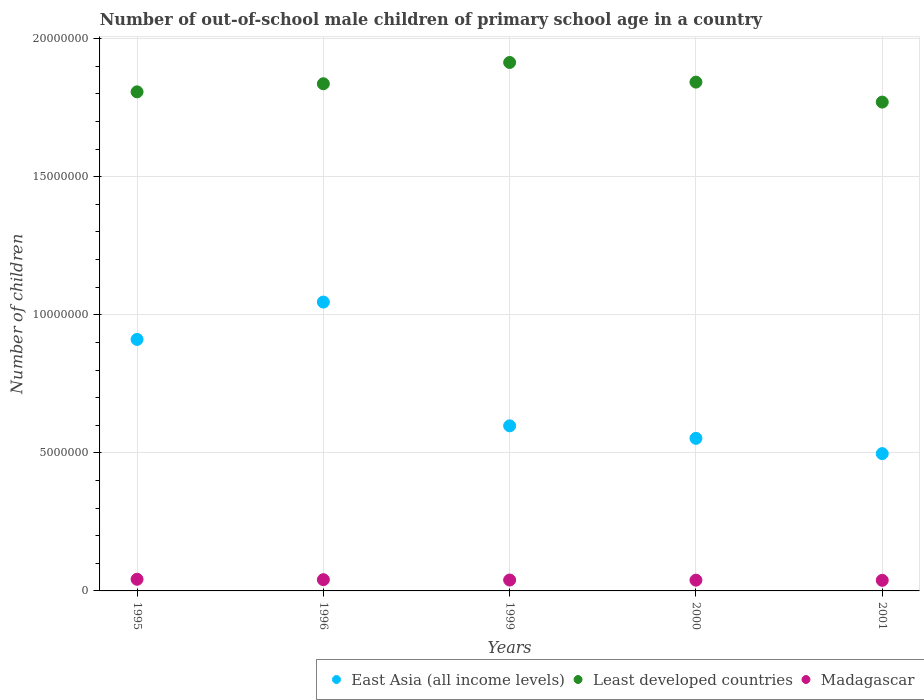Is the number of dotlines equal to the number of legend labels?
Offer a very short reply. Yes. What is the number of out-of-school male children in Madagascar in 1999?
Offer a terse response. 3.95e+05. Across all years, what is the maximum number of out-of-school male children in Madagascar?
Your answer should be very brief. 4.22e+05. Across all years, what is the minimum number of out-of-school male children in Least developed countries?
Offer a very short reply. 1.77e+07. In which year was the number of out-of-school male children in Least developed countries minimum?
Ensure brevity in your answer.  2001. What is the total number of out-of-school male children in Least developed countries in the graph?
Provide a succinct answer. 9.17e+07. What is the difference between the number of out-of-school male children in Least developed countries in 1996 and that in 2000?
Your response must be concise. -6.03e+04. What is the difference between the number of out-of-school male children in Least developed countries in 2001 and the number of out-of-school male children in East Asia (all income levels) in 2000?
Your response must be concise. 1.22e+07. What is the average number of out-of-school male children in Least developed countries per year?
Offer a very short reply. 1.83e+07. In the year 1995, what is the difference between the number of out-of-school male children in East Asia (all income levels) and number of out-of-school male children in Madagascar?
Ensure brevity in your answer.  8.69e+06. In how many years, is the number of out-of-school male children in East Asia (all income levels) greater than 6000000?
Give a very brief answer. 2. What is the ratio of the number of out-of-school male children in Least developed countries in 1995 to that in 2001?
Provide a short and direct response. 1.02. What is the difference between the highest and the second highest number of out-of-school male children in Madagascar?
Provide a short and direct response. 1.47e+04. What is the difference between the highest and the lowest number of out-of-school male children in East Asia (all income levels)?
Give a very brief answer. 5.49e+06. In how many years, is the number of out-of-school male children in Madagascar greater than the average number of out-of-school male children in Madagascar taken over all years?
Provide a succinct answer. 2. Is it the case that in every year, the sum of the number of out-of-school male children in East Asia (all income levels) and number of out-of-school male children in Madagascar  is greater than the number of out-of-school male children in Least developed countries?
Your answer should be very brief. No. Does the number of out-of-school male children in East Asia (all income levels) monotonically increase over the years?
Offer a terse response. No. Is the number of out-of-school male children in Least developed countries strictly less than the number of out-of-school male children in Madagascar over the years?
Offer a very short reply. No. Are the values on the major ticks of Y-axis written in scientific E-notation?
Ensure brevity in your answer.  No. Does the graph contain grids?
Offer a terse response. Yes. How many legend labels are there?
Provide a short and direct response. 3. What is the title of the graph?
Make the answer very short. Number of out-of-school male children of primary school age in a country. Does "Australia" appear as one of the legend labels in the graph?
Ensure brevity in your answer.  No. What is the label or title of the X-axis?
Keep it short and to the point. Years. What is the label or title of the Y-axis?
Ensure brevity in your answer.  Number of children. What is the Number of children of East Asia (all income levels) in 1995?
Your response must be concise. 9.11e+06. What is the Number of children in Least developed countries in 1995?
Your answer should be very brief. 1.81e+07. What is the Number of children in Madagascar in 1995?
Offer a terse response. 4.22e+05. What is the Number of children of East Asia (all income levels) in 1996?
Your answer should be very brief. 1.05e+07. What is the Number of children in Least developed countries in 1996?
Your answer should be very brief. 1.84e+07. What is the Number of children of Madagascar in 1996?
Your response must be concise. 4.07e+05. What is the Number of children in East Asia (all income levels) in 1999?
Make the answer very short. 5.98e+06. What is the Number of children in Least developed countries in 1999?
Give a very brief answer. 1.91e+07. What is the Number of children of Madagascar in 1999?
Your answer should be very brief. 3.95e+05. What is the Number of children in East Asia (all income levels) in 2000?
Offer a very short reply. 5.53e+06. What is the Number of children of Least developed countries in 2000?
Your answer should be compact. 1.84e+07. What is the Number of children of Madagascar in 2000?
Your answer should be compact. 3.90e+05. What is the Number of children of East Asia (all income levels) in 2001?
Offer a terse response. 4.97e+06. What is the Number of children in Least developed countries in 2001?
Keep it short and to the point. 1.77e+07. What is the Number of children in Madagascar in 2001?
Offer a terse response. 3.83e+05. Across all years, what is the maximum Number of children in East Asia (all income levels)?
Give a very brief answer. 1.05e+07. Across all years, what is the maximum Number of children in Least developed countries?
Offer a terse response. 1.91e+07. Across all years, what is the maximum Number of children in Madagascar?
Give a very brief answer. 4.22e+05. Across all years, what is the minimum Number of children of East Asia (all income levels)?
Your answer should be compact. 4.97e+06. Across all years, what is the minimum Number of children in Least developed countries?
Give a very brief answer. 1.77e+07. Across all years, what is the minimum Number of children of Madagascar?
Provide a succinct answer. 3.83e+05. What is the total Number of children in East Asia (all income levels) in the graph?
Your response must be concise. 3.60e+07. What is the total Number of children in Least developed countries in the graph?
Your response must be concise. 9.17e+07. What is the total Number of children of Madagascar in the graph?
Keep it short and to the point. 2.00e+06. What is the difference between the Number of children in East Asia (all income levels) in 1995 and that in 1996?
Give a very brief answer. -1.35e+06. What is the difference between the Number of children of Least developed countries in 1995 and that in 1996?
Provide a succinct answer. -2.93e+05. What is the difference between the Number of children in Madagascar in 1995 and that in 1996?
Provide a short and direct response. 1.47e+04. What is the difference between the Number of children in East Asia (all income levels) in 1995 and that in 1999?
Offer a very short reply. 3.13e+06. What is the difference between the Number of children of Least developed countries in 1995 and that in 1999?
Give a very brief answer. -1.06e+06. What is the difference between the Number of children in Madagascar in 1995 and that in 1999?
Your response must be concise. 2.75e+04. What is the difference between the Number of children of East Asia (all income levels) in 1995 and that in 2000?
Ensure brevity in your answer.  3.58e+06. What is the difference between the Number of children of Least developed countries in 1995 and that in 2000?
Make the answer very short. -3.53e+05. What is the difference between the Number of children of Madagascar in 1995 and that in 2000?
Keep it short and to the point. 3.25e+04. What is the difference between the Number of children of East Asia (all income levels) in 1995 and that in 2001?
Offer a very short reply. 4.14e+06. What is the difference between the Number of children of Least developed countries in 1995 and that in 2001?
Your response must be concise. 3.71e+05. What is the difference between the Number of children of Madagascar in 1995 and that in 2001?
Provide a short and direct response. 3.88e+04. What is the difference between the Number of children of East Asia (all income levels) in 1996 and that in 1999?
Your response must be concise. 4.48e+06. What is the difference between the Number of children of Least developed countries in 1996 and that in 1999?
Keep it short and to the point. -7.71e+05. What is the difference between the Number of children in Madagascar in 1996 and that in 1999?
Your answer should be compact. 1.28e+04. What is the difference between the Number of children of East Asia (all income levels) in 1996 and that in 2000?
Offer a terse response. 4.94e+06. What is the difference between the Number of children of Least developed countries in 1996 and that in 2000?
Provide a short and direct response. -6.03e+04. What is the difference between the Number of children in Madagascar in 1996 and that in 2000?
Ensure brevity in your answer.  1.79e+04. What is the difference between the Number of children in East Asia (all income levels) in 1996 and that in 2001?
Make the answer very short. 5.49e+06. What is the difference between the Number of children of Least developed countries in 1996 and that in 2001?
Offer a very short reply. 6.64e+05. What is the difference between the Number of children in Madagascar in 1996 and that in 2001?
Provide a succinct answer. 2.41e+04. What is the difference between the Number of children in East Asia (all income levels) in 1999 and that in 2000?
Ensure brevity in your answer.  4.53e+05. What is the difference between the Number of children in Least developed countries in 1999 and that in 2000?
Your response must be concise. 7.11e+05. What is the difference between the Number of children in Madagascar in 1999 and that in 2000?
Offer a terse response. 5055. What is the difference between the Number of children in East Asia (all income levels) in 1999 and that in 2001?
Ensure brevity in your answer.  1.01e+06. What is the difference between the Number of children of Least developed countries in 1999 and that in 2001?
Provide a short and direct response. 1.44e+06. What is the difference between the Number of children in Madagascar in 1999 and that in 2001?
Make the answer very short. 1.13e+04. What is the difference between the Number of children in East Asia (all income levels) in 2000 and that in 2001?
Make the answer very short. 5.53e+05. What is the difference between the Number of children of Least developed countries in 2000 and that in 2001?
Offer a terse response. 7.24e+05. What is the difference between the Number of children in Madagascar in 2000 and that in 2001?
Provide a succinct answer. 6256. What is the difference between the Number of children in East Asia (all income levels) in 1995 and the Number of children in Least developed countries in 1996?
Offer a terse response. -9.26e+06. What is the difference between the Number of children of East Asia (all income levels) in 1995 and the Number of children of Madagascar in 1996?
Make the answer very short. 8.70e+06. What is the difference between the Number of children of Least developed countries in 1995 and the Number of children of Madagascar in 1996?
Ensure brevity in your answer.  1.77e+07. What is the difference between the Number of children in East Asia (all income levels) in 1995 and the Number of children in Least developed countries in 1999?
Provide a succinct answer. -1.00e+07. What is the difference between the Number of children of East Asia (all income levels) in 1995 and the Number of children of Madagascar in 1999?
Make the answer very short. 8.71e+06. What is the difference between the Number of children of Least developed countries in 1995 and the Number of children of Madagascar in 1999?
Provide a short and direct response. 1.77e+07. What is the difference between the Number of children in East Asia (all income levels) in 1995 and the Number of children in Least developed countries in 2000?
Make the answer very short. -9.32e+06. What is the difference between the Number of children of East Asia (all income levels) in 1995 and the Number of children of Madagascar in 2000?
Provide a succinct answer. 8.72e+06. What is the difference between the Number of children of Least developed countries in 1995 and the Number of children of Madagascar in 2000?
Your response must be concise. 1.77e+07. What is the difference between the Number of children of East Asia (all income levels) in 1995 and the Number of children of Least developed countries in 2001?
Make the answer very short. -8.59e+06. What is the difference between the Number of children in East Asia (all income levels) in 1995 and the Number of children in Madagascar in 2001?
Offer a very short reply. 8.72e+06. What is the difference between the Number of children of Least developed countries in 1995 and the Number of children of Madagascar in 2001?
Offer a very short reply. 1.77e+07. What is the difference between the Number of children of East Asia (all income levels) in 1996 and the Number of children of Least developed countries in 1999?
Give a very brief answer. -8.68e+06. What is the difference between the Number of children of East Asia (all income levels) in 1996 and the Number of children of Madagascar in 1999?
Provide a short and direct response. 1.01e+07. What is the difference between the Number of children in Least developed countries in 1996 and the Number of children in Madagascar in 1999?
Keep it short and to the point. 1.80e+07. What is the difference between the Number of children of East Asia (all income levels) in 1996 and the Number of children of Least developed countries in 2000?
Your answer should be very brief. -7.97e+06. What is the difference between the Number of children of East Asia (all income levels) in 1996 and the Number of children of Madagascar in 2000?
Your response must be concise. 1.01e+07. What is the difference between the Number of children of Least developed countries in 1996 and the Number of children of Madagascar in 2000?
Your answer should be very brief. 1.80e+07. What is the difference between the Number of children in East Asia (all income levels) in 1996 and the Number of children in Least developed countries in 2001?
Keep it short and to the point. -7.24e+06. What is the difference between the Number of children in East Asia (all income levels) in 1996 and the Number of children in Madagascar in 2001?
Give a very brief answer. 1.01e+07. What is the difference between the Number of children of Least developed countries in 1996 and the Number of children of Madagascar in 2001?
Make the answer very short. 1.80e+07. What is the difference between the Number of children in East Asia (all income levels) in 1999 and the Number of children in Least developed countries in 2000?
Provide a short and direct response. -1.24e+07. What is the difference between the Number of children in East Asia (all income levels) in 1999 and the Number of children in Madagascar in 2000?
Make the answer very short. 5.59e+06. What is the difference between the Number of children in Least developed countries in 1999 and the Number of children in Madagascar in 2000?
Keep it short and to the point. 1.87e+07. What is the difference between the Number of children of East Asia (all income levels) in 1999 and the Number of children of Least developed countries in 2001?
Keep it short and to the point. -1.17e+07. What is the difference between the Number of children in East Asia (all income levels) in 1999 and the Number of children in Madagascar in 2001?
Your answer should be compact. 5.60e+06. What is the difference between the Number of children of Least developed countries in 1999 and the Number of children of Madagascar in 2001?
Ensure brevity in your answer.  1.88e+07. What is the difference between the Number of children in East Asia (all income levels) in 2000 and the Number of children in Least developed countries in 2001?
Ensure brevity in your answer.  -1.22e+07. What is the difference between the Number of children of East Asia (all income levels) in 2000 and the Number of children of Madagascar in 2001?
Offer a very short reply. 5.14e+06. What is the difference between the Number of children of Least developed countries in 2000 and the Number of children of Madagascar in 2001?
Your answer should be very brief. 1.80e+07. What is the average Number of children in East Asia (all income levels) per year?
Give a very brief answer. 7.21e+06. What is the average Number of children in Least developed countries per year?
Offer a very short reply. 1.83e+07. What is the average Number of children of Madagascar per year?
Make the answer very short. 3.99e+05. In the year 1995, what is the difference between the Number of children of East Asia (all income levels) and Number of children of Least developed countries?
Provide a short and direct response. -8.97e+06. In the year 1995, what is the difference between the Number of children of East Asia (all income levels) and Number of children of Madagascar?
Ensure brevity in your answer.  8.69e+06. In the year 1995, what is the difference between the Number of children of Least developed countries and Number of children of Madagascar?
Keep it short and to the point. 1.77e+07. In the year 1996, what is the difference between the Number of children of East Asia (all income levels) and Number of children of Least developed countries?
Give a very brief answer. -7.91e+06. In the year 1996, what is the difference between the Number of children of East Asia (all income levels) and Number of children of Madagascar?
Offer a very short reply. 1.01e+07. In the year 1996, what is the difference between the Number of children of Least developed countries and Number of children of Madagascar?
Make the answer very short. 1.80e+07. In the year 1999, what is the difference between the Number of children in East Asia (all income levels) and Number of children in Least developed countries?
Your answer should be very brief. -1.32e+07. In the year 1999, what is the difference between the Number of children in East Asia (all income levels) and Number of children in Madagascar?
Ensure brevity in your answer.  5.58e+06. In the year 1999, what is the difference between the Number of children in Least developed countries and Number of children in Madagascar?
Your answer should be compact. 1.87e+07. In the year 2000, what is the difference between the Number of children in East Asia (all income levels) and Number of children in Least developed countries?
Offer a terse response. -1.29e+07. In the year 2000, what is the difference between the Number of children of East Asia (all income levels) and Number of children of Madagascar?
Provide a short and direct response. 5.14e+06. In the year 2000, what is the difference between the Number of children in Least developed countries and Number of children in Madagascar?
Keep it short and to the point. 1.80e+07. In the year 2001, what is the difference between the Number of children in East Asia (all income levels) and Number of children in Least developed countries?
Make the answer very short. -1.27e+07. In the year 2001, what is the difference between the Number of children of East Asia (all income levels) and Number of children of Madagascar?
Provide a succinct answer. 4.59e+06. In the year 2001, what is the difference between the Number of children in Least developed countries and Number of children in Madagascar?
Your answer should be very brief. 1.73e+07. What is the ratio of the Number of children of East Asia (all income levels) in 1995 to that in 1996?
Give a very brief answer. 0.87. What is the ratio of the Number of children in Least developed countries in 1995 to that in 1996?
Your answer should be very brief. 0.98. What is the ratio of the Number of children in Madagascar in 1995 to that in 1996?
Keep it short and to the point. 1.04. What is the ratio of the Number of children of East Asia (all income levels) in 1995 to that in 1999?
Make the answer very short. 1.52. What is the ratio of the Number of children of Least developed countries in 1995 to that in 1999?
Give a very brief answer. 0.94. What is the ratio of the Number of children in Madagascar in 1995 to that in 1999?
Give a very brief answer. 1.07. What is the ratio of the Number of children of East Asia (all income levels) in 1995 to that in 2000?
Your answer should be very brief. 1.65. What is the ratio of the Number of children of Least developed countries in 1995 to that in 2000?
Your answer should be compact. 0.98. What is the ratio of the Number of children of Madagascar in 1995 to that in 2000?
Your answer should be compact. 1.08. What is the ratio of the Number of children in East Asia (all income levels) in 1995 to that in 2001?
Your response must be concise. 1.83. What is the ratio of the Number of children in Least developed countries in 1995 to that in 2001?
Your response must be concise. 1.02. What is the ratio of the Number of children of Madagascar in 1995 to that in 2001?
Provide a succinct answer. 1.1. What is the ratio of the Number of children of East Asia (all income levels) in 1996 to that in 1999?
Ensure brevity in your answer.  1.75. What is the ratio of the Number of children of Least developed countries in 1996 to that in 1999?
Your response must be concise. 0.96. What is the ratio of the Number of children in Madagascar in 1996 to that in 1999?
Your answer should be compact. 1.03. What is the ratio of the Number of children of East Asia (all income levels) in 1996 to that in 2000?
Your response must be concise. 1.89. What is the ratio of the Number of children of Least developed countries in 1996 to that in 2000?
Give a very brief answer. 1. What is the ratio of the Number of children of Madagascar in 1996 to that in 2000?
Give a very brief answer. 1.05. What is the ratio of the Number of children of East Asia (all income levels) in 1996 to that in 2001?
Provide a succinct answer. 2.1. What is the ratio of the Number of children in Least developed countries in 1996 to that in 2001?
Offer a very short reply. 1.04. What is the ratio of the Number of children in Madagascar in 1996 to that in 2001?
Make the answer very short. 1.06. What is the ratio of the Number of children of East Asia (all income levels) in 1999 to that in 2000?
Offer a terse response. 1.08. What is the ratio of the Number of children of Least developed countries in 1999 to that in 2000?
Your answer should be compact. 1.04. What is the ratio of the Number of children of Madagascar in 1999 to that in 2000?
Make the answer very short. 1.01. What is the ratio of the Number of children of East Asia (all income levels) in 1999 to that in 2001?
Offer a terse response. 1.2. What is the ratio of the Number of children in Least developed countries in 1999 to that in 2001?
Make the answer very short. 1.08. What is the ratio of the Number of children of Madagascar in 1999 to that in 2001?
Your answer should be compact. 1.03. What is the ratio of the Number of children in East Asia (all income levels) in 2000 to that in 2001?
Offer a terse response. 1.11. What is the ratio of the Number of children in Least developed countries in 2000 to that in 2001?
Your answer should be very brief. 1.04. What is the ratio of the Number of children in Madagascar in 2000 to that in 2001?
Give a very brief answer. 1.02. What is the difference between the highest and the second highest Number of children of East Asia (all income levels)?
Your answer should be very brief. 1.35e+06. What is the difference between the highest and the second highest Number of children in Least developed countries?
Ensure brevity in your answer.  7.11e+05. What is the difference between the highest and the second highest Number of children in Madagascar?
Your answer should be compact. 1.47e+04. What is the difference between the highest and the lowest Number of children of East Asia (all income levels)?
Your answer should be very brief. 5.49e+06. What is the difference between the highest and the lowest Number of children in Least developed countries?
Give a very brief answer. 1.44e+06. What is the difference between the highest and the lowest Number of children in Madagascar?
Keep it short and to the point. 3.88e+04. 